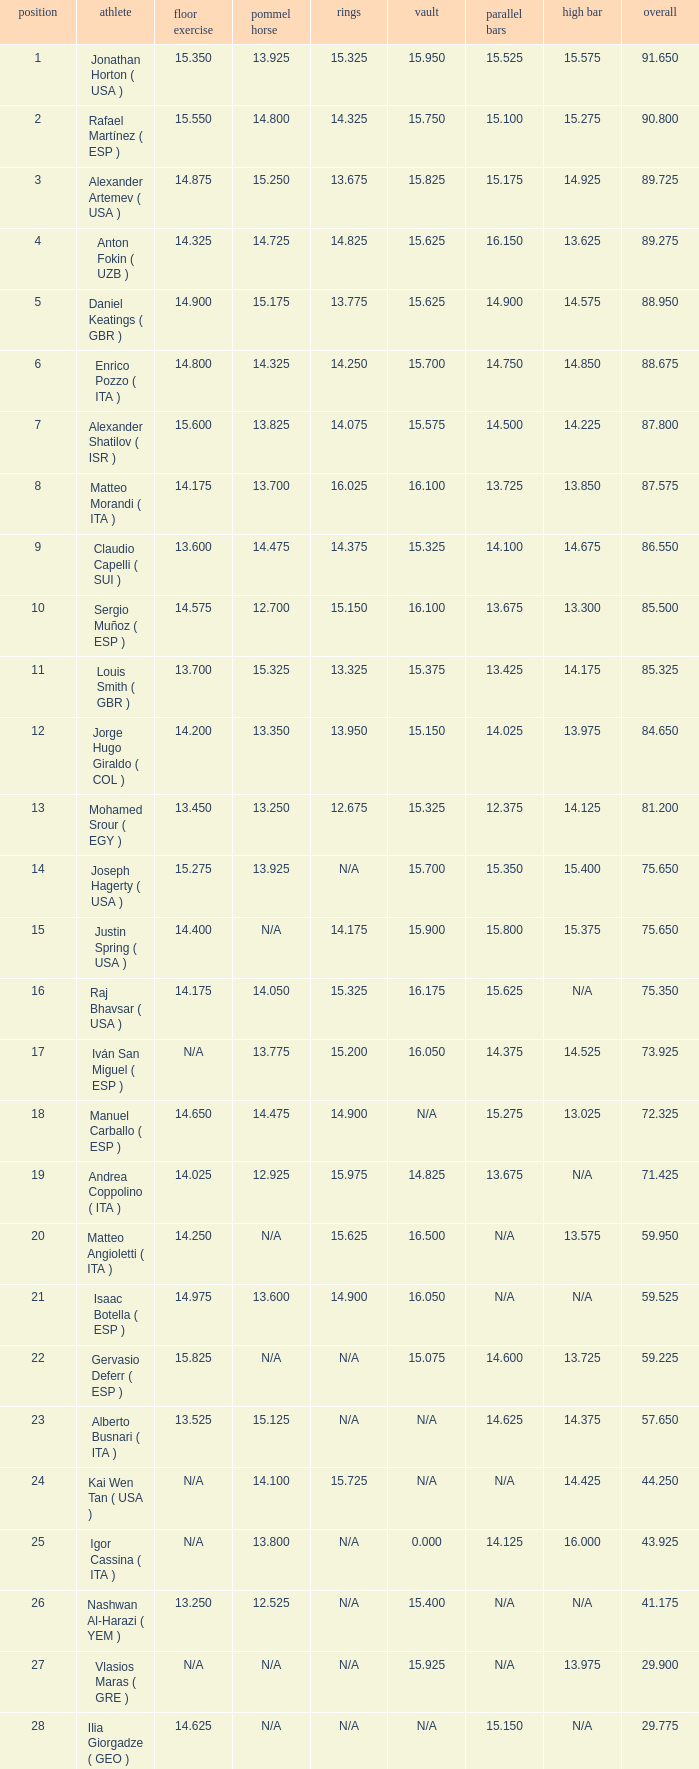If the horizontal bar is unavailable and the floor is 1 15.625. 